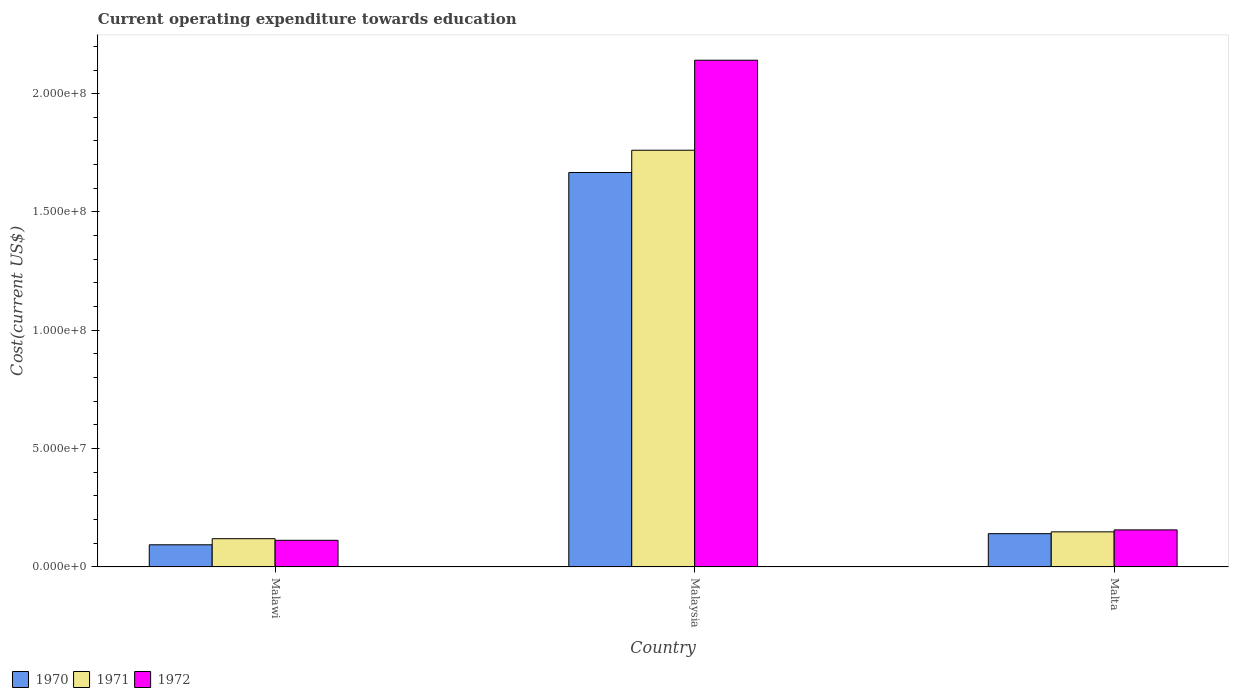How many groups of bars are there?
Your answer should be compact. 3. Are the number of bars per tick equal to the number of legend labels?
Your answer should be compact. Yes. Are the number of bars on each tick of the X-axis equal?
Make the answer very short. Yes. What is the label of the 2nd group of bars from the left?
Make the answer very short. Malaysia. What is the expenditure towards education in 1972 in Malta?
Give a very brief answer. 1.56e+07. Across all countries, what is the maximum expenditure towards education in 1972?
Offer a terse response. 2.14e+08. Across all countries, what is the minimum expenditure towards education in 1972?
Offer a terse response. 1.12e+07. In which country was the expenditure towards education in 1971 maximum?
Give a very brief answer. Malaysia. In which country was the expenditure towards education in 1972 minimum?
Offer a very short reply. Malawi. What is the total expenditure towards education in 1970 in the graph?
Give a very brief answer. 1.90e+08. What is the difference between the expenditure towards education in 1970 in Malawi and that in Malta?
Ensure brevity in your answer.  -4.69e+06. What is the difference between the expenditure towards education in 1970 in Malta and the expenditure towards education in 1971 in Malawi?
Your answer should be compact. 2.11e+06. What is the average expenditure towards education in 1970 per country?
Offer a terse response. 6.34e+07. What is the difference between the expenditure towards education of/in 1971 and expenditure towards education of/in 1970 in Malaysia?
Your answer should be very brief. 9.42e+06. What is the ratio of the expenditure towards education in 1972 in Malawi to that in Malaysia?
Keep it short and to the point. 0.05. Is the difference between the expenditure towards education in 1971 in Malawi and Malta greater than the difference between the expenditure towards education in 1970 in Malawi and Malta?
Provide a succinct answer. Yes. What is the difference between the highest and the second highest expenditure towards education in 1971?
Provide a succinct answer. -1.64e+08. What is the difference between the highest and the lowest expenditure towards education in 1970?
Your answer should be compact. 1.57e+08. Are the values on the major ticks of Y-axis written in scientific E-notation?
Offer a very short reply. Yes. Does the graph contain grids?
Keep it short and to the point. No. Where does the legend appear in the graph?
Give a very brief answer. Bottom left. How many legend labels are there?
Offer a very short reply. 3. How are the legend labels stacked?
Ensure brevity in your answer.  Horizontal. What is the title of the graph?
Give a very brief answer. Current operating expenditure towards education. What is the label or title of the Y-axis?
Your answer should be compact. Cost(current US$). What is the Cost(current US$) of 1970 in Malawi?
Provide a short and direct response. 9.35e+06. What is the Cost(current US$) in 1971 in Malawi?
Offer a very short reply. 1.19e+07. What is the Cost(current US$) in 1972 in Malawi?
Make the answer very short. 1.12e+07. What is the Cost(current US$) in 1970 in Malaysia?
Make the answer very short. 1.67e+08. What is the Cost(current US$) of 1971 in Malaysia?
Ensure brevity in your answer.  1.76e+08. What is the Cost(current US$) of 1972 in Malaysia?
Provide a short and direct response. 2.14e+08. What is the Cost(current US$) of 1970 in Malta?
Provide a short and direct response. 1.40e+07. What is the Cost(current US$) of 1971 in Malta?
Keep it short and to the point. 1.48e+07. What is the Cost(current US$) of 1972 in Malta?
Provide a short and direct response. 1.56e+07. Across all countries, what is the maximum Cost(current US$) in 1970?
Your response must be concise. 1.67e+08. Across all countries, what is the maximum Cost(current US$) in 1971?
Provide a short and direct response. 1.76e+08. Across all countries, what is the maximum Cost(current US$) in 1972?
Your answer should be very brief. 2.14e+08. Across all countries, what is the minimum Cost(current US$) in 1970?
Your response must be concise. 9.35e+06. Across all countries, what is the minimum Cost(current US$) of 1971?
Give a very brief answer. 1.19e+07. Across all countries, what is the minimum Cost(current US$) of 1972?
Offer a terse response. 1.12e+07. What is the total Cost(current US$) in 1970 in the graph?
Provide a succinct answer. 1.90e+08. What is the total Cost(current US$) in 1971 in the graph?
Keep it short and to the point. 2.03e+08. What is the total Cost(current US$) of 1972 in the graph?
Ensure brevity in your answer.  2.41e+08. What is the difference between the Cost(current US$) in 1970 in Malawi and that in Malaysia?
Offer a terse response. -1.57e+08. What is the difference between the Cost(current US$) in 1971 in Malawi and that in Malaysia?
Your answer should be very brief. -1.64e+08. What is the difference between the Cost(current US$) in 1972 in Malawi and that in Malaysia?
Your response must be concise. -2.03e+08. What is the difference between the Cost(current US$) of 1970 in Malawi and that in Malta?
Give a very brief answer. -4.69e+06. What is the difference between the Cost(current US$) of 1971 in Malawi and that in Malta?
Your answer should be very brief. -2.89e+06. What is the difference between the Cost(current US$) of 1972 in Malawi and that in Malta?
Your response must be concise. -4.40e+06. What is the difference between the Cost(current US$) in 1970 in Malaysia and that in Malta?
Provide a succinct answer. 1.53e+08. What is the difference between the Cost(current US$) of 1971 in Malaysia and that in Malta?
Provide a short and direct response. 1.61e+08. What is the difference between the Cost(current US$) in 1972 in Malaysia and that in Malta?
Offer a very short reply. 1.98e+08. What is the difference between the Cost(current US$) of 1970 in Malawi and the Cost(current US$) of 1971 in Malaysia?
Provide a short and direct response. -1.67e+08. What is the difference between the Cost(current US$) in 1970 in Malawi and the Cost(current US$) in 1972 in Malaysia?
Keep it short and to the point. -2.05e+08. What is the difference between the Cost(current US$) of 1971 in Malawi and the Cost(current US$) of 1972 in Malaysia?
Ensure brevity in your answer.  -2.02e+08. What is the difference between the Cost(current US$) in 1970 in Malawi and the Cost(current US$) in 1971 in Malta?
Keep it short and to the point. -5.47e+06. What is the difference between the Cost(current US$) in 1970 in Malawi and the Cost(current US$) in 1972 in Malta?
Your answer should be compact. -6.29e+06. What is the difference between the Cost(current US$) of 1971 in Malawi and the Cost(current US$) of 1972 in Malta?
Your answer should be very brief. -3.71e+06. What is the difference between the Cost(current US$) in 1970 in Malaysia and the Cost(current US$) in 1971 in Malta?
Provide a short and direct response. 1.52e+08. What is the difference between the Cost(current US$) in 1970 in Malaysia and the Cost(current US$) in 1972 in Malta?
Offer a terse response. 1.51e+08. What is the difference between the Cost(current US$) in 1971 in Malaysia and the Cost(current US$) in 1972 in Malta?
Provide a succinct answer. 1.60e+08. What is the average Cost(current US$) of 1970 per country?
Offer a very short reply. 6.34e+07. What is the average Cost(current US$) of 1971 per country?
Give a very brief answer. 6.76e+07. What is the average Cost(current US$) of 1972 per country?
Your answer should be very brief. 8.03e+07. What is the difference between the Cost(current US$) in 1970 and Cost(current US$) in 1971 in Malawi?
Give a very brief answer. -2.58e+06. What is the difference between the Cost(current US$) in 1970 and Cost(current US$) in 1972 in Malawi?
Your response must be concise. -1.89e+06. What is the difference between the Cost(current US$) of 1971 and Cost(current US$) of 1972 in Malawi?
Offer a very short reply. 6.86e+05. What is the difference between the Cost(current US$) of 1970 and Cost(current US$) of 1971 in Malaysia?
Offer a terse response. -9.42e+06. What is the difference between the Cost(current US$) of 1970 and Cost(current US$) of 1972 in Malaysia?
Your answer should be very brief. -4.75e+07. What is the difference between the Cost(current US$) of 1971 and Cost(current US$) of 1972 in Malaysia?
Provide a short and direct response. -3.80e+07. What is the difference between the Cost(current US$) of 1970 and Cost(current US$) of 1971 in Malta?
Your answer should be compact. -7.75e+05. What is the difference between the Cost(current US$) in 1970 and Cost(current US$) in 1972 in Malta?
Your answer should be very brief. -1.60e+06. What is the difference between the Cost(current US$) in 1971 and Cost(current US$) in 1972 in Malta?
Offer a terse response. -8.26e+05. What is the ratio of the Cost(current US$) of 1970 in Malawi to that in Malaysia?
Ensure brevity in your answer.  0.06. What is the ratio of the Cost(current US$) of 1971 in Malawi to that in Malaysia?
Provide a succinct answer. 0.07. What is the ratio of the Cost(current US$) in 1972 in Malawi to that in Malaysia?
Make the answer very short. 0.05. What is the ratio of the Cost(current US$) of 1970 in Malawi to that in Malta?
Give a very brief answer. 0.67. What is the ratio of the Cost(current US$) of 1971 in Malawi to that in Malta?
Offer a terse response. 0.81. What is the ratio of the Cost(current US$) in 1972 in Malawi to that in Malta?
Your response must be concise. 0.72. What is the ratio of the Cost(current US$) in 1970 in Malaysia to that in Malta?
Give a very brief answer. 11.87. What is the ratio of the Cost(current US$) in 1971 in Malaysia to that in Malta?
Make the answer very short. 11.89. What is the ratio of the Cost(current US$) of 1972 in Malaysia to that in Malta?
Ensure brevity in your answer.  13.69. What is the difference between the highest and the second highest Cost(current US$) of 1970?
Keep it short and to the point. 1.53e+08. What is the difference between the highest and the second highest Cost(current US$) in 1971?
Provide a succinct answer. 1.61e+08. What is the difference between the highest and the second highest Cost(current US$) in 1972?
Offer a terse response. 1.98e+08. What is the difference between the highest and the lowest Cost(current US$) in 1970?
Ensure brevity in your answer.  1.57e+08. What is the difference between the highest and the lowest Cost(current US$) in 1971?
Provide a short and direct response. 1.64e+08. What is the difference between the highest and the lowest Cost(current US$) of 1972?
Offer a terse response. 2.03e+08. 